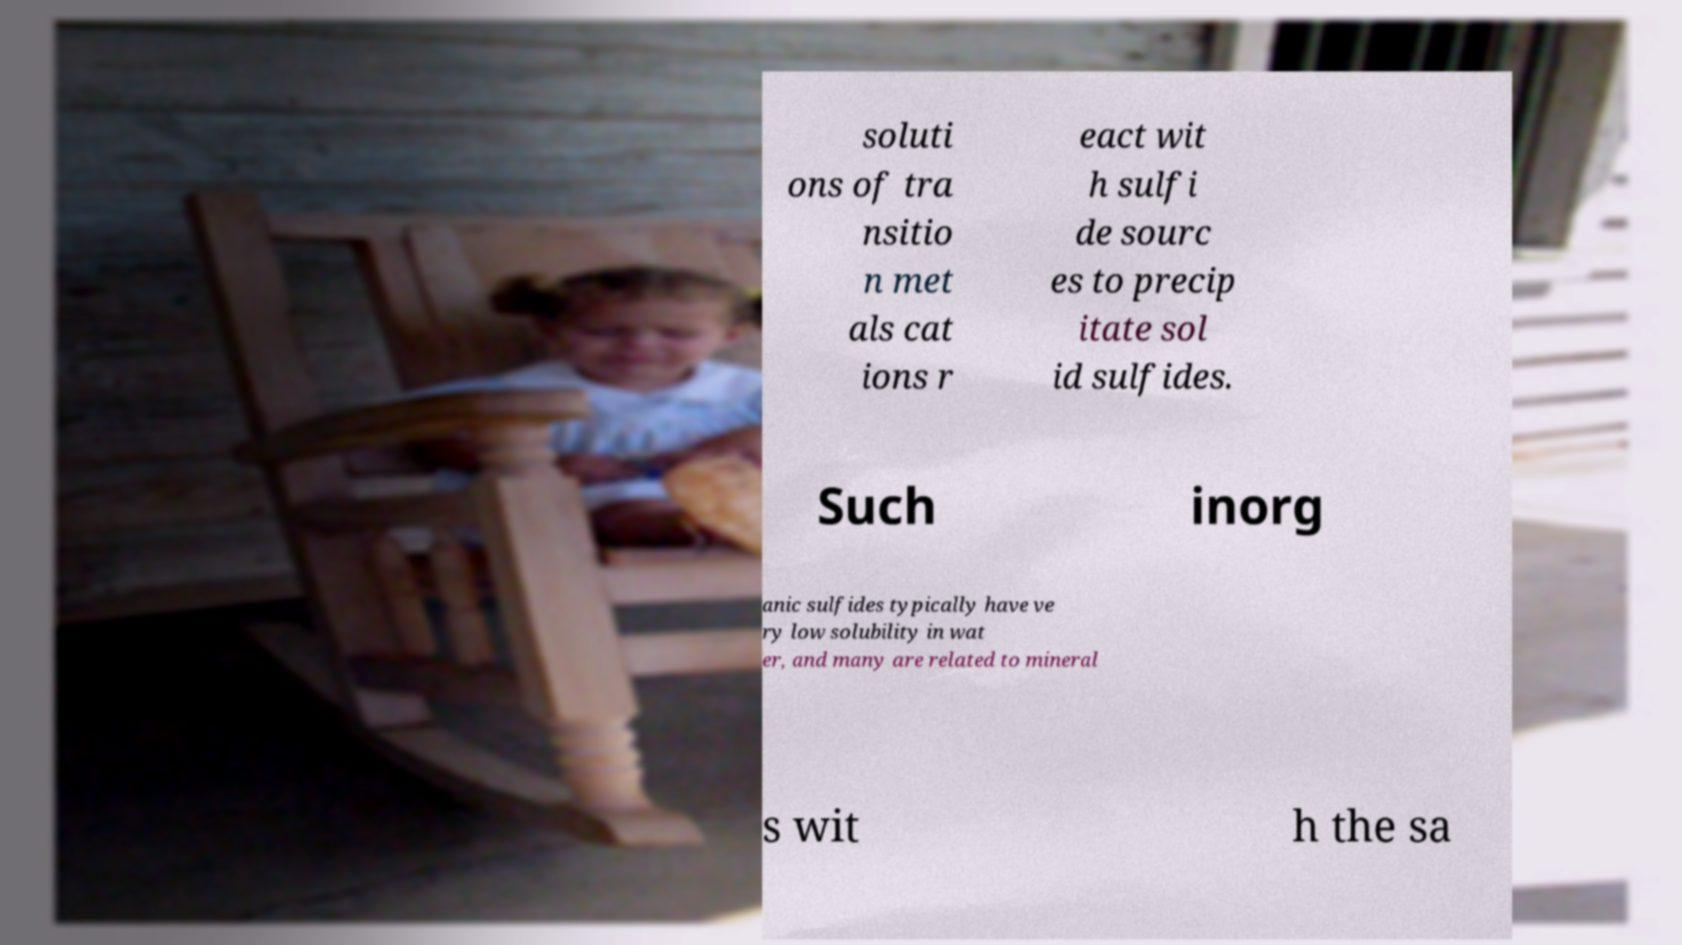There's text embedded in this image that I need extracted. Can you transcribe it verbatim? soluti ons of tra nsitio n met als cat ions r eact wit h sulfi de sourc es to precip itate sol id sulfides. Such inorg anic sulfides typically have ve ry low solubility in wat er, and many are related to mineral s wit h the sa 